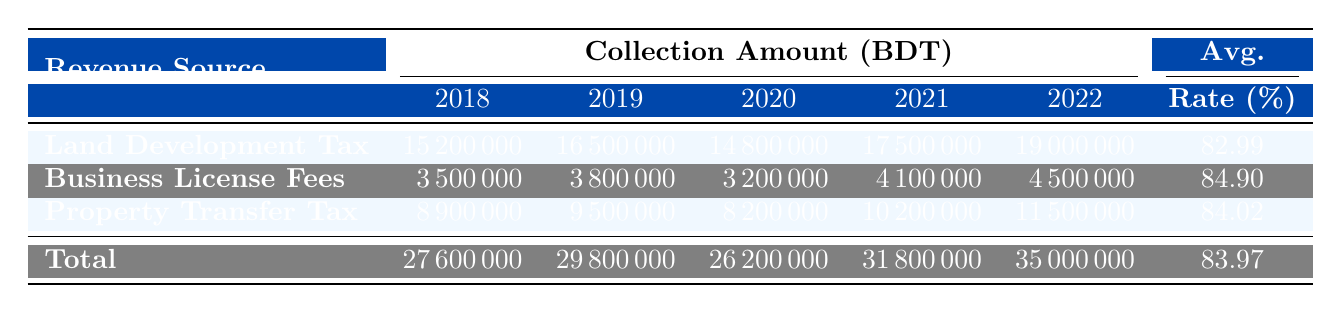What was the collection amount for Land Development Tax in 2021? The table shows the collection amounts for the Land Development Tax in various years. Looking at the year 2021, it indicates that the collection amount was 17,500,000 BDT.
Answer: 17,500,000 BDT Which revenue source had the highest average collection rate over the five years? To find the highest average collection rate, we need to look at the average rates for each revenue source. The averages are 82.99% for Land Development Tax, 84.90% for Business License Fees, and 84.02% for Property Transfer Tax. The highest is for Business License Fees at 84.90%.
Answer: Business License Fees What is the total collection amount for 2020 across all revenue sources? The table lists the collection amounts for 2020: Land Development Tax is 14,800,000 BDT, Business License Fees is 3,200,000 BDT, and Property Transfer Tax is 8,200,000 BDT. Summing these gives 14,800,000 + 3,200,000 + 8,200,000 = 26,200,000 BDT.
Answer: 26,200,000 BDT Was there a decrease in the collection amount for Business License Fees from 2019 to 2020? The table shows that the collection for Business License Fees was 3,800,000 BDT in 2019 and decreased to 3,200,000 BDT in 2020. Since 3,200,000 is less than 3,800,000, it confirms a decrease occurred.
Answer: Yes Calculate the increase in the total collection amount from 2018 to 2022. The total collection amounts for the years are: 27,600,000 BDT for 2018 and 35,000,000 BDT for 2022. The increase can be calculated as 35,000,000 - 27,600,000 = 7,400,000 BDT.
Answer: 7,400,000 BDT Did Panchagarh Sadar have a consistent increase in the collection amount for Land Development Tax from 2018 to 2022? The collection amounts for Panchagarh Sadar for Land Development Tax were 15,200,000 BDT in 2018, 16,500,000 BDT in 2019, 14,800,000 BDT in 2020, 17,500,000 BDT in 2021, and 19,000,000 BDT in 2022. Observing the values, there was a decrease between 2019 and 2020, hence it cannot be considered consistent.
Answer: No What was the target amount for Property Transfer Tax in 2021 compared to its collection amount? The target amount for Property Transfer Tax in 2021 was 12,000,000 BDT, while the collection amount was 10,200,000 BDT. Since the collection amount is less than the target amount, it shows a shortfall.
Answer: The target was higher Which municipality contributed the least to the total collection amount in 2020? The collection amounts for 2020 were 14,800,000 BDT for Panchagarh Sadar, 3,200,000 for Tetulia, and 8,200,000 for Boda, totaling 26,200,000 BDT. The lowest contribution comes from Tetulia with 3,200,000 BDT.
Answer: Tetulia 